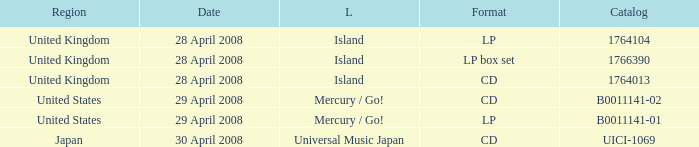What is the Label of the B0011141-01 Catalog? Mercury / Go!. 